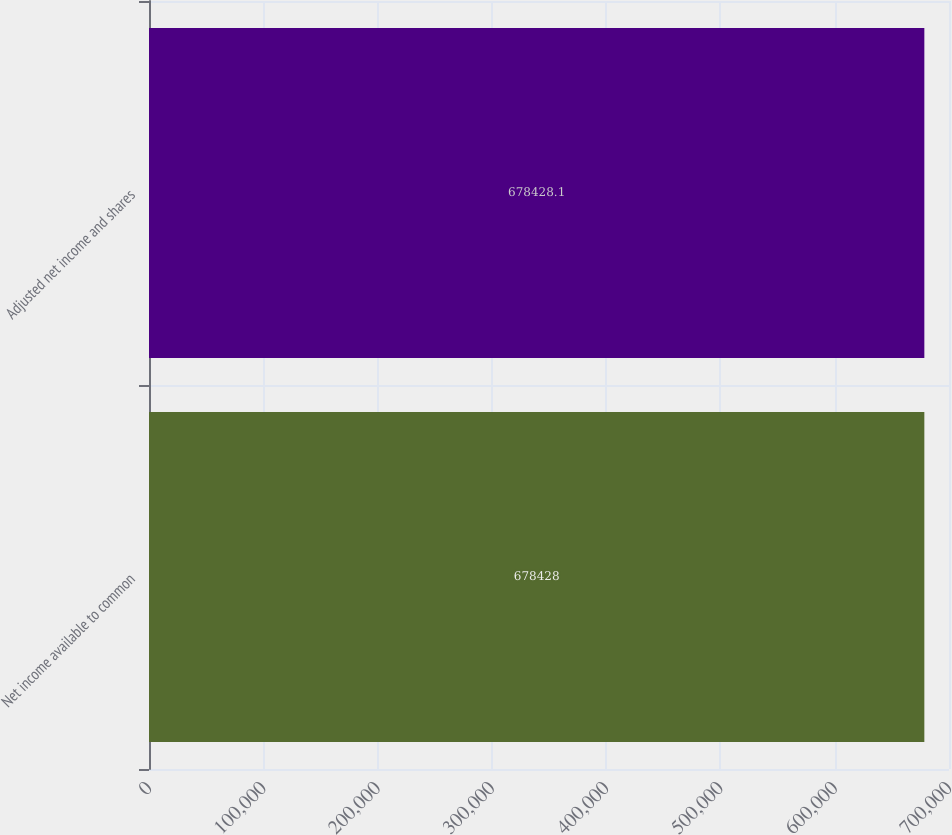<chart> <loc_0><loc_0><loc_500><loc_500><bar_chart><fcel>Net income available to common<fcel>Adjusted net income and shares<nl><fcel>678428<fcel>678428<nl></chart> 